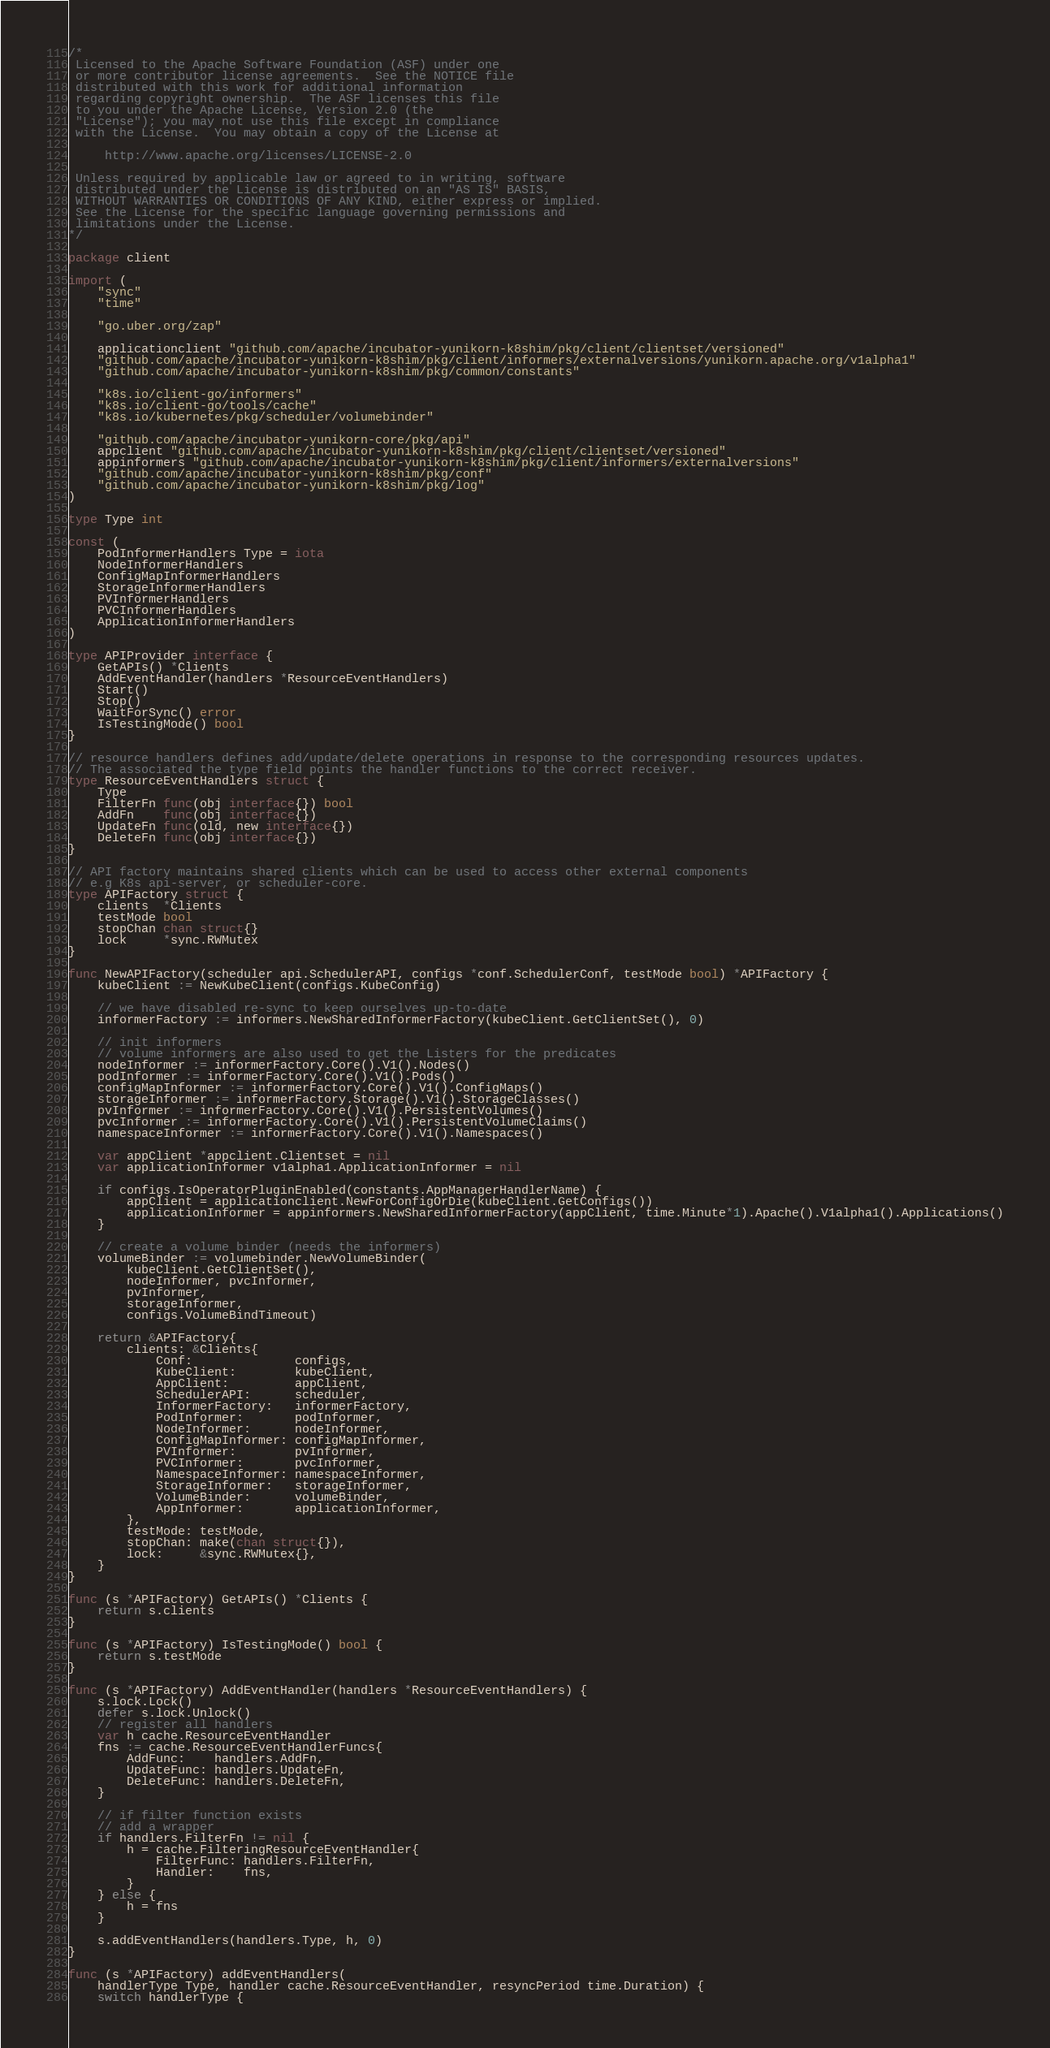Convert code to text. <code><loc_0><loc_0><loc_500><loc_500><_Go_>/*
 Licensed to the Apache Software Foundation (ASF) under one
 or more contributor license agreements.  See the NOTICE file
 distributed with this work for additional information
 regarding copyright ownership.  The ASF licenses this file
 to you under the Apache License, Version 2.0 (the
 "License"); you may not use this file except in compliance
 with the License.  You may obtain a copy of the License at

     http://www.apache.org/licenses/LICENSE-2.0

 Unless required by applicable law or agreed to in writing, software
 distributed under the License is distributed on an "AS IS" BASIS,
 WITHOUT WARRANTIES OR CONDITIONS OF ANY KIND, either express or implied.
 See the License for the specific language governing permissions and
 limitations under the License.
*/

package client

import (
	"sync"
	"time"

	"go.uber.org/zap"

	applicationclient "github.com/apache/incubator-yunikorn-k8shim/pkg/client/clientset/versioned"
	"github.com/apache/incubator-yunikorn-k8shim/pkg/client/informers/externalversions/yunikorn.apache.org/v1alpha1"
	"github.com/apache/incubator-yunikorn-k8shim/pkg/common/constants"

	"k8s.io/client-go/informers"
	"k8s.io/client-go/tools/cache"
	"k8s.io/kubernetes/pkg/scheduler/volumebinder"

	"github.com/apache/incubator-yunikorn-core/pkg/api"
	appclient "github.com/apache/incubator-yunikorn-k8shim/pkg/client/clientset/versioned"
	appinformers "github.com/apache/incubator-yunikorn-k8shim/pkg/client/informers/externalversions"
	"github.com/apache/incubator-yunikorn-k8shim/pkg/conf"
	"github.com/apache/incubator-yunikorn-k8shim/pkg/log"
)

type Type int

const (
	PodInformerHandlers Type = iota
	NodeInformerHandlers
	ConfigMapInformerHandlers
	StorageInformerHandlers
	PVInformerHandlers
	PVCInformerHandlers
	ApplicationInformerHandlers
)

type APIProvider interface {
	GetAPIs() *Clients
	AddEventHandler(handlers *ResourceEventHandlers)
	Start()
	Stop()
	WaitForSync() error
	IsTestingMode() bool
}

// resource handlers defines add/update/delete operations in response to the corresponding resources updates.
// The associated the type field points the handler functions to the correct receiver.
type ResourceEventHandlers struct {
	Type
	FilterFn func(obj interface{}) bool
	AddFn    func(obj interface{})
	UpdateFn func(old, new interface{})
	DeleteFn func(obj interface{})
}

// API factory maintains shared clients which can be used to access other external components
// e.g K8s api-server, or scheduler-core.
type APIFactory struct {
	clients  *Clients
	testMode bool
	stopChan chan struct{}
	lock     *sync.RWMutex
}

func NewAPIFactory(scheduler api.SchedulerAPI, configs *conf.SchedulerConf, testMode bool) *APIFactory {
	kubeClient := NewKubeClient(configs.KubeConfig)

	// we have disabled re-sync to keep ourselves up-to-date
	informerFactory := informers.NewSharedInformerFactory(kubeClient.GetClientSet(), 0)

	// init informers
	// volume informers are also used to get the Listers for the predicates
	nodeInformer := informerFactory.Core().V1().Nodes()
	podInformer := informerFactory.Core().V1().Pods()
	configMapInformer := informerFactory.Core().V1().ConfigMaps()
	storageInformer := informerFactory.Storage().V1().StorageClasses()
	pvInformer := informerFactory.Core().V1().PersistentVolumes()
	pvcInformer := informerFactory.Core().V1().PersistentVolumeClaims()
	namespaceInformer := informerFactory.Core().V1().Namespaces()

	var appClient *appclient.Clientset = nil
	var applicationInformer v1alpha1.ApplicationInformer = nil

	if configs.IsOperatorPluginEnabled(constants.AppManagerHandlerName) {
		appClient = applicationclient.NewForConfigOrDie(kubeClient.GetConfigs())
		applicationInformer = appinformers.NewSharedInformerFactory(appClient, time.Minute*1).Apache().V1alpha1().Applications()
	}

	// create a volume binder (needs the informers)
	volumeBinder := volumebinder.NewVolumeBinder(
		kubeClient.GetClientSet(),
		nodeInformer, pvcInformer,
		pvInformer,
		storageInformer,
		configs.VolumeBindTimeout)

	return &APIFactory{
		clients: &Clients{
			Conf:              configs,
			KubeClient:        kubeClient,
			AppClient:         appClient,
			SchedulerAPI:      scheduler,
			InformerFactory:   informerFactory,
			PodInformer:       podInformer,
			NodeInformer:      nodeInformer,
			ConfigMapInformer: configMapInformer,
			PVInformer:        pvInformer,
			PVCInformer:       pvcInformer,
			NamespaceInformer: namespaceInformer,
			StorageInformer:   storageInformer,
			VolumeBinder:      volumeBinder,
			AppInformer:       applicationInformer,
		},
		testMode: testMode,
		stopChan: make(chan struct{}),
		lock:     &sync.RWMutex{},
	}
}

func (s *APIFactory) GetAPIs() *Clients {
	return s.clients
}

func (s *APIFactory) IsTestingMode() bool {
	return s.testMode
}

func (s *APIFactory) AddEventHandler(handlers *ResourceEventHandlers) {
	s.lock.Lock()
	defer s.lock.Unlock()
	// register all handlers
	var h cache.ResourceEventHandler
	fns := cache.ResourceEventHandlerFuncs{
		AddFunc:    handlers.AddFn,
		UpdateFunc: handlers.UpdateFn,
		DeleteFunc: handlers.DeleteFn,
	}

	// if filter function exists
	// add a wrapper
	if handlers.FilterFn != nil {
		h = cache.FilteringResourceEventHandler{
			FilterFunc: handlers.FilterFn,
			Handler:    fns,
		}
	} else {
		h = fns
	}

	s.addEventHandlers(handlers.Type, h, 0)
}

func (s *APIFactory) addEventHandlers(
	handlerType Type, handler cache.ResourceEventHandler, resyncPeriod time.Duration) {
	switch handlerType {</code> 